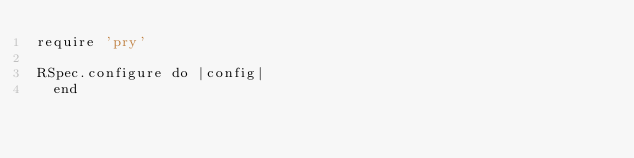Convert code to text. <code><loc_0><loc_0><loc_500><loc_500><_Ruby_>require 'pry'

RSpec.configure do |config|
  end
</code> 